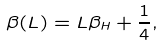<formula> <loc_0><loc_0><loc_500><loc_500>\beta ( L ) = L \beta _ { H } + { \frac { 1 } { 4 } } ,</formula> 